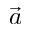Convert formula to latex. <formula><loc_0><loc_0><loc_500><loc_500>\vec { a }</formula> 